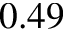Convert formula to latex. <formula><loc_0><loc_0><loc_500><loc_500>0 . 4 9</formula> 